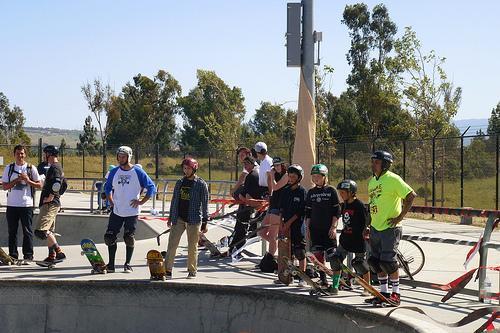How many people are in this photo?
Give a very brief answer. 12. How many skateboards are visible?
Give a very brief answer. 8. How many skateboarders are lined up ready to skate?
Give a very brief answer. 7. 